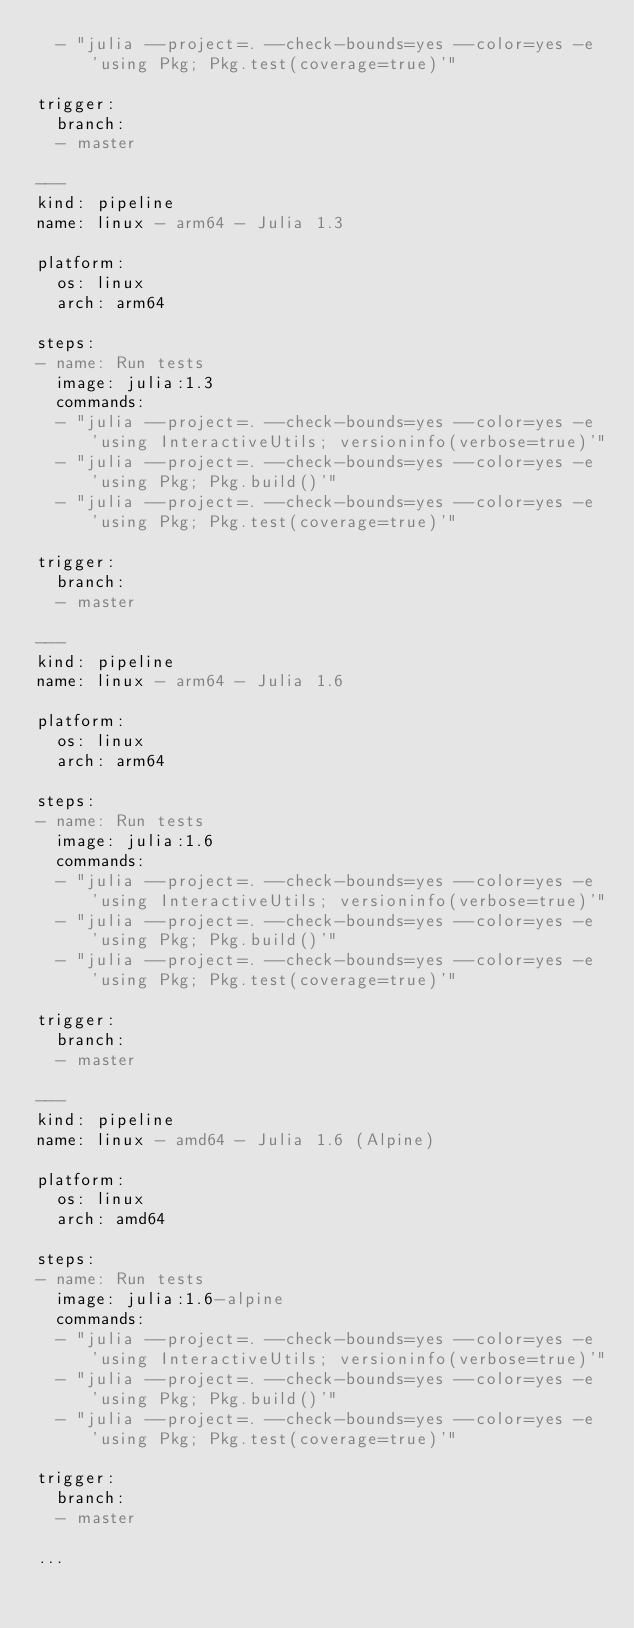Convert code to text. <code><loc_0><loc_0><loc_500><loc_500><_YAML_>  - "julia --project=. --check-bounds=yes --color=yes -e 'using Pkg; Pkg.test(coverage=true)'"

trigger:
  branch:
  - master

---
kind: pipeline
name: linux - arm64 - Julia 1.3

platform:
  os: linux
  arch: arm64

steps:
- name: Run tests
  image: julia:1.3
  commands:
  - "julia --project=. --check-bounds=yes --color=yes -e 'using InteractiveUtils; versioninfo(verbose=true)'"
  - "julia --project=. --check-bounds=yes --color=yes -e 'using Pkg; Pkg.build()'"
  - "julia --project=. --check-bounds=yes --color=yes -e 'using Pkg; Pkg.test(coverage=true)'"

trigger:
  branch:
  - master

---
kind: pipeline
name: linux - arm64 - Julia 1.6

platform:
  os: linux
  arch: arm64

steps:
- name: Run tests
  image: julia:1.6
  commands:
  - "julia --project=. --check-bounds=yes --color=yes -e 'using InteractiveUtils; versioninfo(verbose=true)'"
  - "julia --project=. --check-bounds=yes --color=yes -e 'using Pkg; Pkg.build()'"
  - "julia --project=. --check-bounds=yes --color=yes -e 'using Pkg; Pkg.test(coverage=true)'"

trigger:
  branch:
  - master

---
kind: pipeline
name: linux - amd64 - Julia 1.6 (Alpine)

platform:
  os: linux
  arch: amd64

steps:
- name: Run tests
  image: julia:1.6-alpine
  commands:
  - "julia --project=. --check-bounds=yes --color=yes -e 'using InteractiveUtils; versioninfo(verbose=true)'"
  - "julia --project=. --check-bounds=yes --color=yes -e 'using Pkg; Pkg.build()'"
  - "julia --project=. --check-bounds=yes --color=yes -e 'using Pkg; Pkg.test(coverage=true)'"

trigger:
  branch:
  - master

...
</code> 